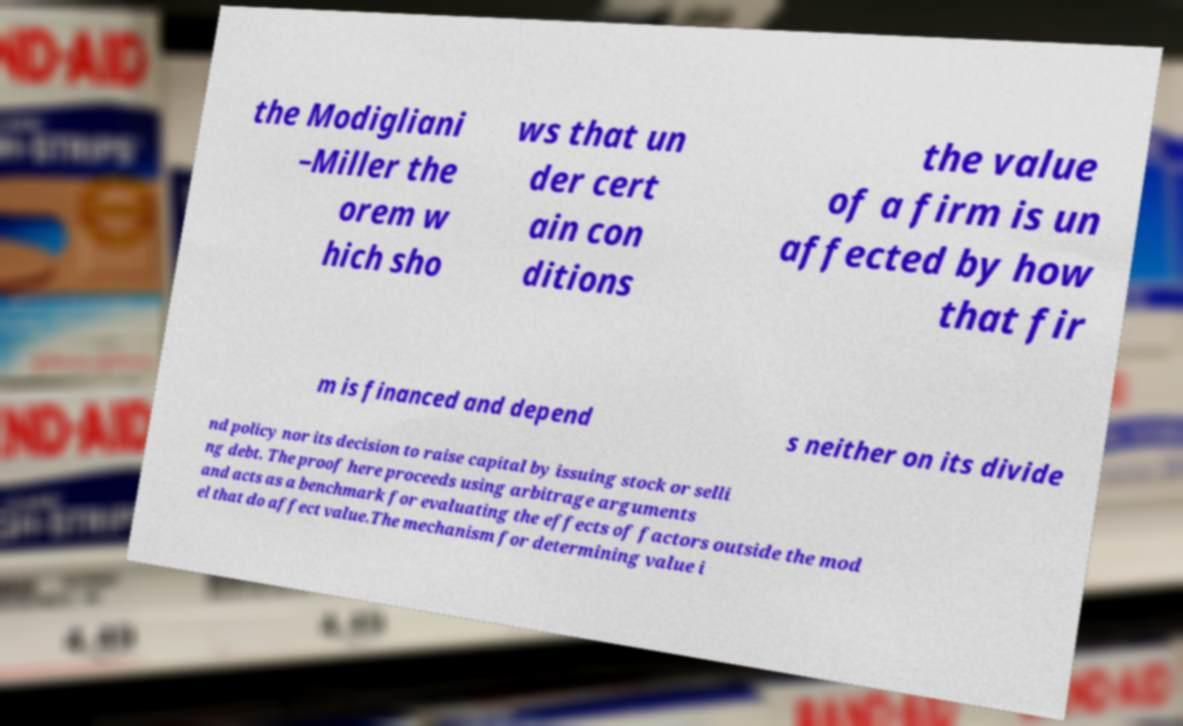Can you accurately transcribe the text from the provided image for me? the Modigliani –Miller the orem w hich sho ws that un der cert ain con ditions the value of a firm is un affected by how that fir m is financed and depend s neither on its divide nd policy nor its decision to raise capital by issuing stock or selli ng debt. The proof here proceeds using arbitrage arguments and acts as a benchmark for evaluating the effects of factors outside the mod el that do affect value.The mechanism for determining value i 